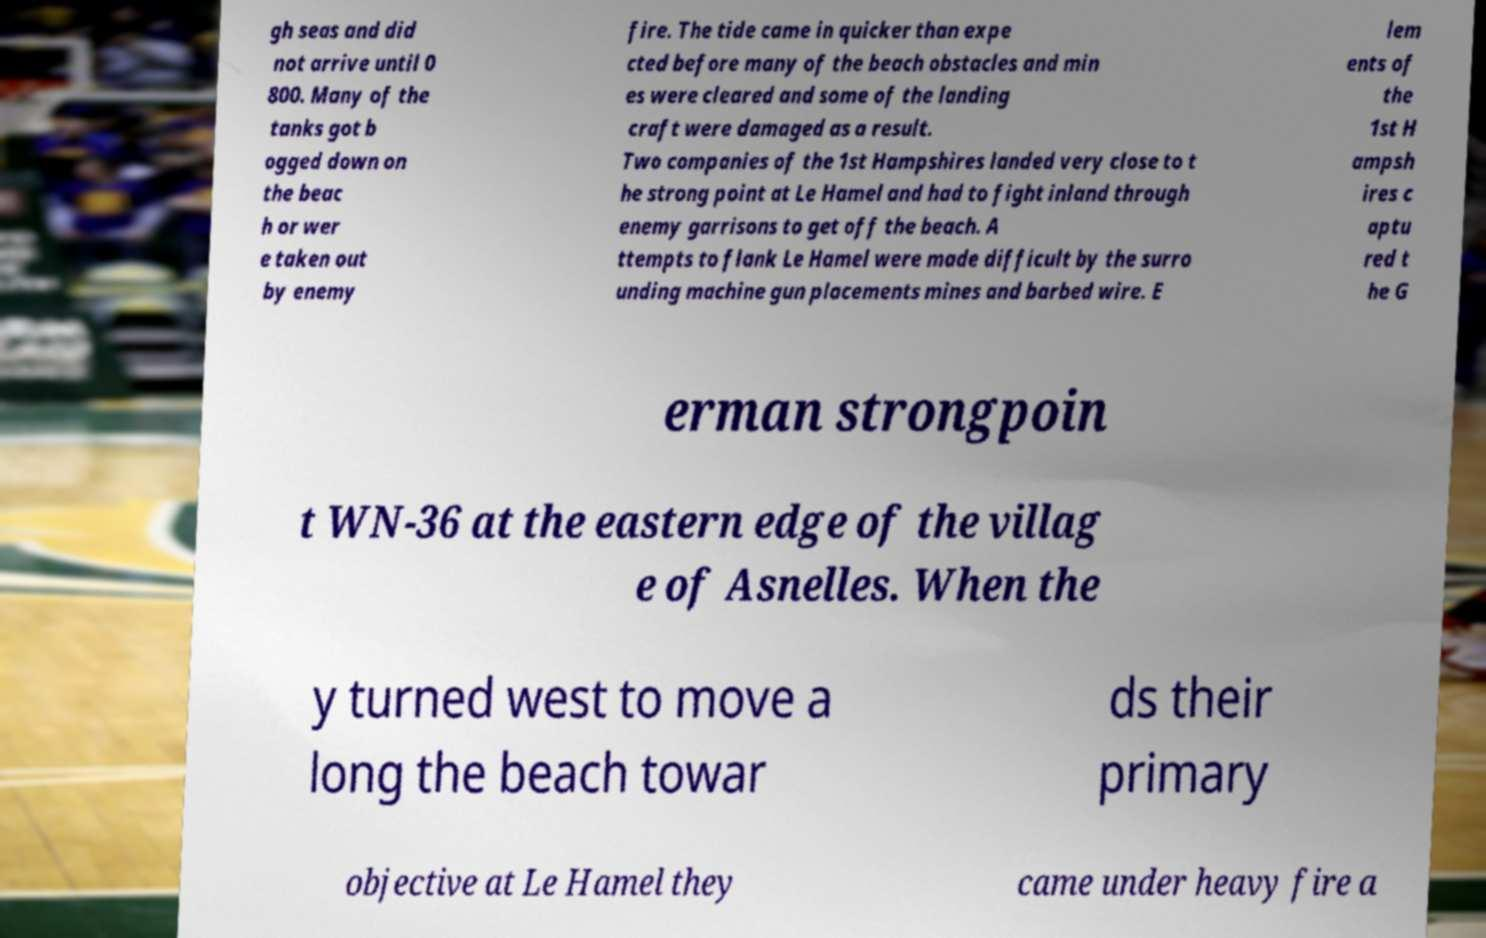I need the written content from this picture converted into text. Can you do that? gh seas and did not arrive until 0 800. Many of the tanks got b ogged down on the beac h or wer e taken out by enemy fire. The tide came in quicker than expe cted before many of the beach obstacles and min es were cleared and some of the landing craft were damaged as a result. Two companies of the 1st Hampshires landed very close to t he strong point at Le Hamel and had to fight inland through enemy garrisons to get off the beach. A ttempts to flank Le Hamel were made difficult by the surro unding machine gun placements mines and barbed wire. E lem ents of the 1st H ampsh ires c aptu red t he G erman strongpoin t WN-36 at the eastern edge of the villag e of Asnelles. When the y turned west to move a long the beach towar ds their primary objective at Le Hamel they came under heavy fire a 